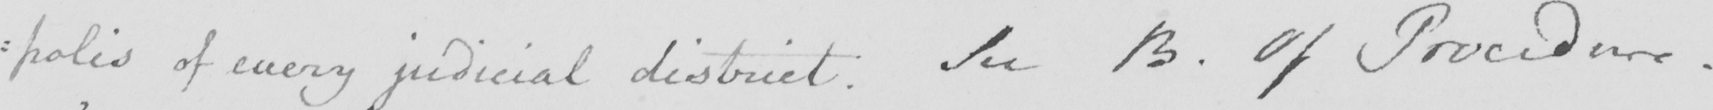Transcribe the text shown in this historical manuscript line. :polis of every judicial district. See B. Of Procedure. 